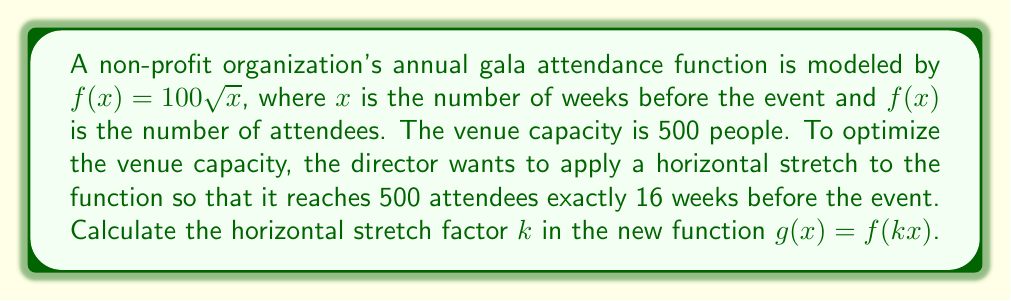Show me your answer to this math problem. 1) The original function is $f(x) = 100\sqrt{x}$

2) We want to find $k$ such that $g(x) = f(kx) = 100\sqrt{kx}$

3) We know that we want $g(16) = 500$, so:

   $500 = 100\sqrt{16k}$

4) Divide both sides by 100:
   
   $5 = \sqrt{16k}$

5) Square both sides:

   $25 = 16k$

6) Divide both sides by 16:

   $\frac{25}{16} = k$

7) This fraction can be reduced to:

   $\frac{25}{16} = \frac{25}{2^4} = \frac{5^2}{2^4}$

Therefore, the horizontal stretch factor $k$ is $\frac{5^2}{2^4}$.
Answer: $\frac{5^2}{2^4}$ 